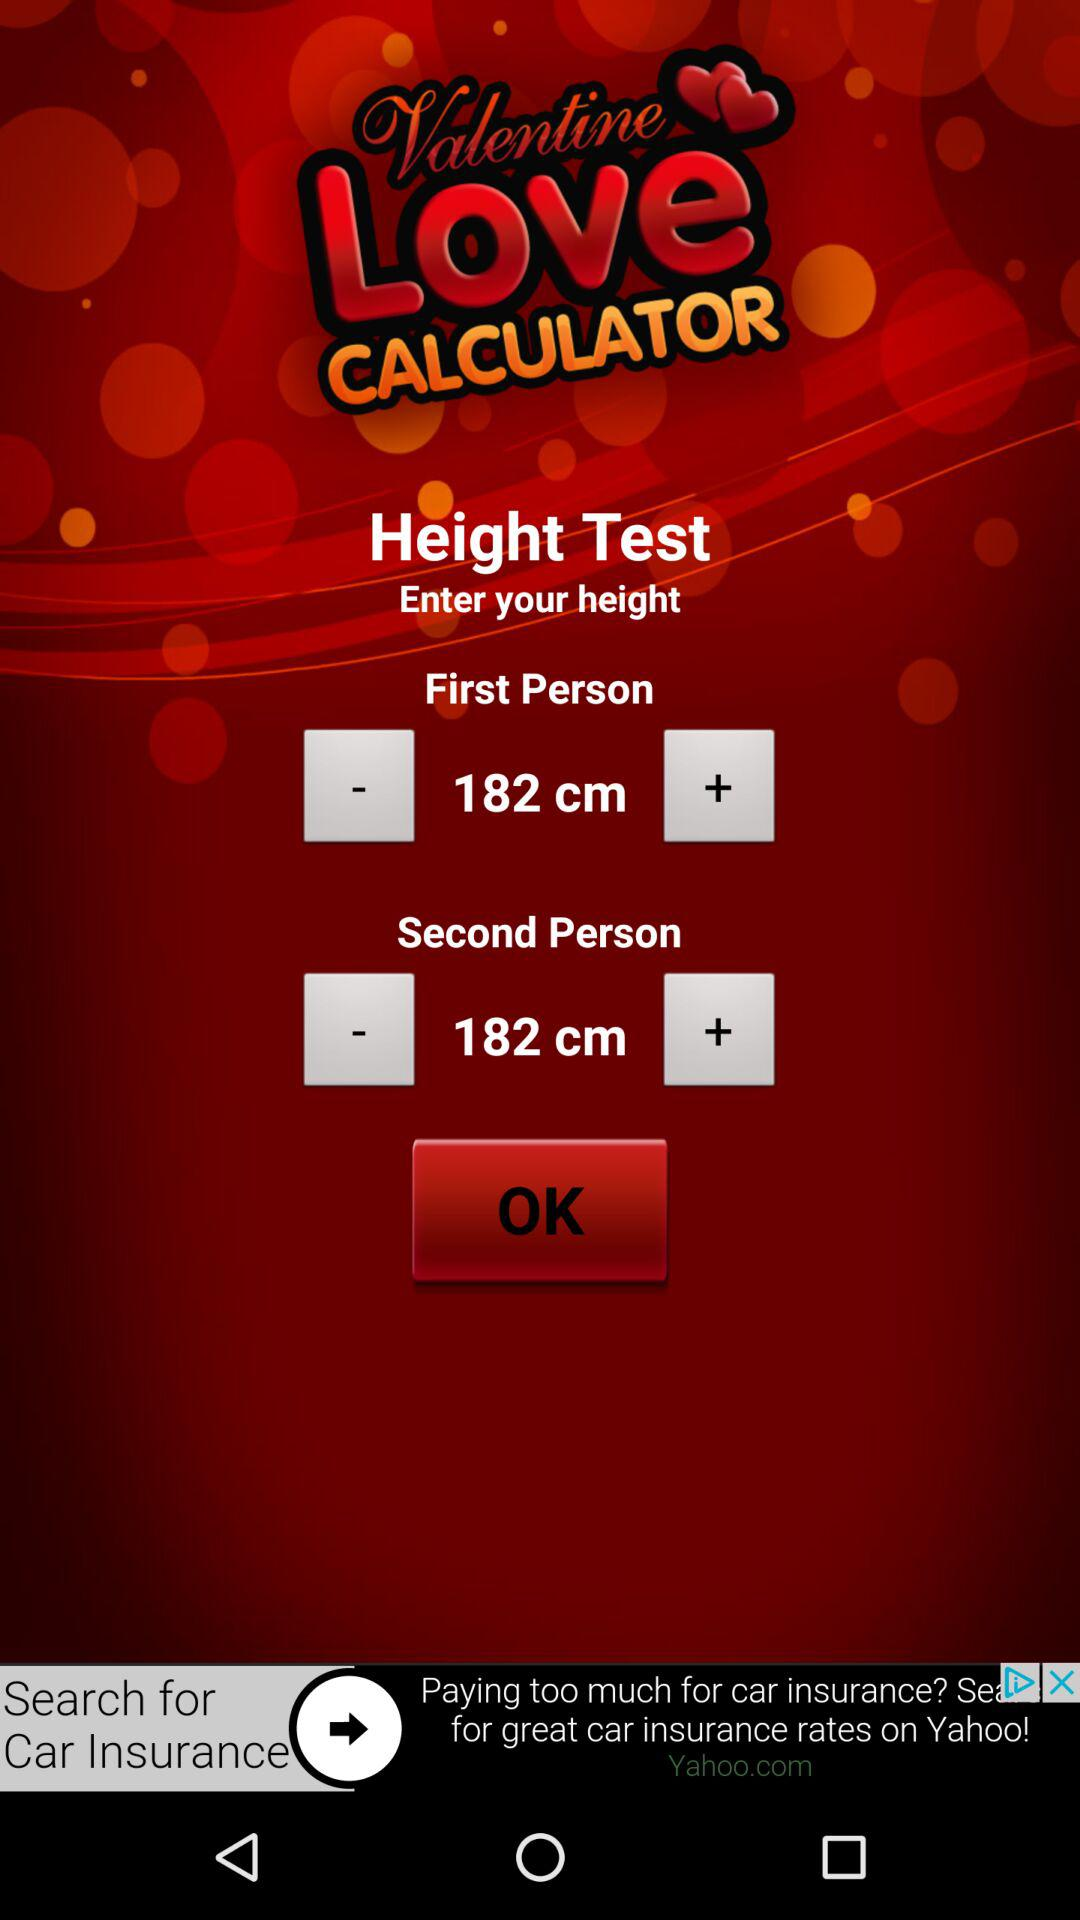What is the first person's height? The first person's height is 182 cm. 